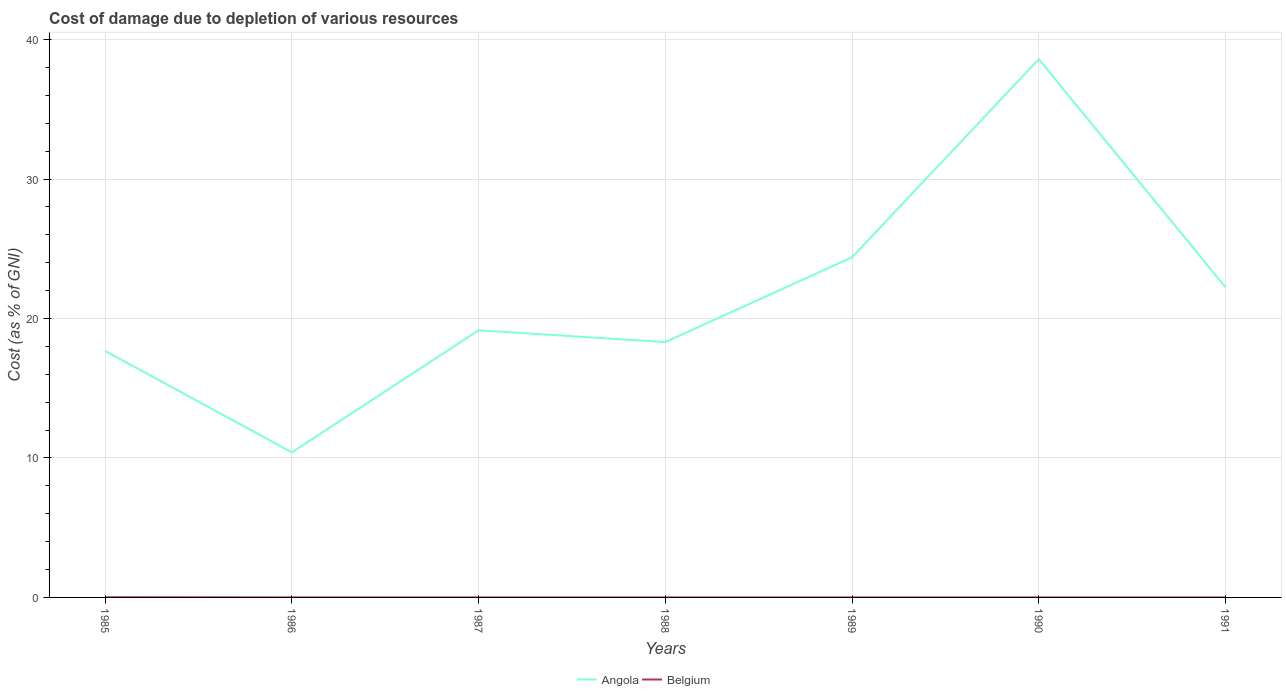Is the number of lines equal to the number of legend labels?
Your answer should be compact. Yes. Across all years, what is the maximum cost of damage caused due to the depletion of various resources in Belgium?
Ensure brevity in your answer.  0. In which year was the cost of damage caused due to the depletion of various resources in Angola maximum?
Offer a very short reply. 1986. What is the total cost of damage caused due to the depletion of various resources in Belgium in the graph?
Your answer should be compact. 3.8111591028627015e-5. What is the difference between the highest and the second highest cost of damage caused due to the depletion of various resources in Belgium?
Offer a very short reply. 0.02. What is the difference between the highest and the lowest cost of damage caused due to the depletion of various resources in Belgium?
Give a very brief answer. 1. How many years are there in the graph?
Offer a terse response. 7. What is the difference between two consecutive major ticks on the Y-axis?
Give a very brief answer. 10. Does the graph contain grids?
Offer a terse response. Yes. How many legend labels are there?
Ensure brevity in your answer.  2. What is the title of the graph?
Offer a very short reply. Cost of damage due to depletion of various resources. What is the label or title of the X-axis?
Make the answer very short. Years. What is the label or title of the Y-axis?
Your answer should be compact. Cost (as % of GNI). What is the Cost (as % of GNI) of Angola in 1985?
Provide a succinct answer. 17.68. What is the Cost (as % of GNI) in Belgium in 1985?
Your answer should be very brief. 0.02. What is the Cost (as % of GNI) in Angola in 1986?
Offer a very short reply. 10.4. What is the Cost (as % of GNI) in Belgium in 1986?
Keep it short and to the point. 0. What is the Cost (as % of GNI) in Angola in 1987?
Keep it short and to the point. 19.15. What is the Cost (as % of GNI) in Belgium in 1987?
Your response must be concise. 0. What is the Cost (as % of GNI) in Angola in 1988?
Ensure brevity in your answer.  18.31. What is the Cost (as % of GNI) in Belgium in 1988?
Your answer should be very brief. 0. What is the Cost (as % of GNI) in Angola in 1989?
Offer a terse response. 24.39. What is the Cost (as % of GNI) of Belgium in 1989?
Your answer should be very brief. 0. What is the Cost (as % of GNI) of Angola in 1990?
Offer a very short reply. 38.59. What is the Cost (as % of GNI) in Belgium in 1990?
Make the answer very short. 0. What is the Cost (as % of GNI) in Angola in 1991?
Your answer should be very brief. 22.24. What is the Cost (as % of GNI) in Belgium in 1991?
Your response must be concise. 0. Across all years, what is the maximum Cost (as % of GNI) of Angola?
Provide a short and direct response. 38.59. Across all years, what is the maximum Cost (as % of GNI) of Belgium?
Give a very brief answer. 0.02. Across all years, what is the minimum Cost (as % of GNI) in Angola?
Your response must be concise. 10.4. Across all years, what is the minimum Cost (as % of GNI) of Belgium?
Your answer should be compact. 0. What is the total Cost (as % of GNI) in Angola in the graph?
Provide a succinct answer. 150.76. What is the total Cost (as % of GNI) of Belgium in the graph?
Your answer should be very brief. 0.02. What is the difference between the Cost (as % of GNI) in Angola in 1985 and that in 1986?
Your answer should be very brief. 7.27. What is the difference between the Cost (as % of GNI) in Belgium in 1985 and that in 1986?
Offer a very short reply. 0.01. What is the difference between the Cost (as % of GNI) of Angola in 1985 and that in 1987?
Your answer should be compact. -1.48. What is the difference between the Cost (as % of GNI) of Belgium in 1985 and that in 1987?
Provide a short and direct response. 0.02. What is the difference between the Cost (as % of GNI) in Angola in 1985 and that in 1988?
Offer a very short reply. -0.63. What is the difference between the Cost (as % of GNI) in Belgium in 1985 and that in 1988?
Your answer should be compact. 0.02. What is the difference between the Cost (as % of GNI) of Angola in 1985 and that in 1989?
Give a very brief answer. -6.71. What is the difference between the Cost (as % of GNI) in Belgium in 1985 and that in 1989?
Provide a succinct answer. 0.02. What is the difference between the Cost (as % of GNI) in Angola in 1985 and that in 1990?
Your response must be concise. -20.92. What is the difference between the Cost (as % of GNI) in Belgium in 1985 and that in 1990?
Offer a very short reply. 0.02. What is the difference between the Cost (as % of GNI) of Angola in 1985 and that in 1991?
Give a very brief answer. -4.56. What is the difference between the Cost (as % of GNI) of Belgium in 1985 and that in 1991?
Ensure brevity in your answer.  0.02. What is the difference between the Cost (as % of GNI) in Angola in 1986 and that in 1987?
Provide a short and direct response. -8.75. What is the difference between the Cost (as % of GNI) in Angola in 1986 and that in 1988?
Ensure brevity in your answer.  -7.91. What is the difference between the Cost (as % of GNI) in Belgium in 1986 and that in 1988?
Provide a short and direct response. 0. What is the difference between the Cost (as % of GNI) in Angola in 1986 and that in 1989?
Make the answer very short. -13.99. What is the difference between the Cost (as % of GNI) in Belgium in 1986 and that in 1989?
Ensure brevity in your answer.  0. What is the difference between the Cost (as % of GNI) in Angola in 1986 and that in 1990?
Offer a terse response. -28.19. What is the difference between the Cost (as % of GNI) of Belgium in 1986 and that in 1990?
Ensure brevity in your answer.  0. What is the difference between the Cost (as % of GNI) in Angola in 1986 and that in 1991?
Make the answer very short. -11.84. What is the difference between the Cost (as % of GNI) in Belgium in 1986 and that in 1991?
Your response must be concise. 0. What is the difference between the Cost (as % of GNI) of Angola in 1987 and that in 1988?
Keep it short and to the point. 0.84. What is the difference between the Cost (as % of GNI) of Angola in 1987 and that in 1989?
Ensure brevity in your answer.  -5.24. What is the difference between the Cost (as % of GNI) of Angola in 1987 and that in 1990?
Make the answer very short. -19.44. What is the difference between the Cost (as % of GNI) in Belgium in 1987 and that in 1990?
Give a very brief answer. 0. What is the difference between the Cost (as % of GNI) of Angola in 1987 and that in 1991?
Make the answer very short. -3.09. What is the difference between the Cost (as % of GNI) of Belgium in 1987 and that in 1991?
Provide a short and direct response. 0. What is the difference between the Cost (as % of GNI) in Angola in 1988 and that in 1989?
Make the answer very short. -6.08. What is the difference between the Cost (as % of GNI) in Belgium in 1988 and that in 1989?
Make the answer very short. 0. What is the difference between the Cost (as % of GNI) in Angola in 1988 and that in 1990?
Give a very brief answer. -20.28. What is the difference between the Cost (as % of GNI) in Angola in 1988 and that in 1991?
Offer a terse response. -3.93. What is the difference between the Cost (as % of GNI) of Angola in 1989 and that in 1990?
Provide a succinct answer. -14.21. What is the difference between the Cost (as % of GNI) in Belgium in 1989 and that in 1990?
Provide a succinct answer. 0. What is the difference between the Cost (as % of GNI) of Angola in 1989 and that in 1991?
Keep it short and to the point. 2.15. What is the difference between the Cost (as % of GNI) in Belgium in 1989 and that in 1991?
Your response must be concise. 0. What is the difference between the Cost (as % of GNI) in Angola in 1990 and that in 1991?
Offer a terse response. 16.36. What is the difference between the Cost (as % of GNI) in Angola in 1985 and the Cost (as % of GNI) in Belgium in 1986?
Offer a very short reply. 17.67. What is the difference between the Cost (as % of GNI) of Angola in 1985 and the Cost (as % of GNI) of Belgium in 1987?
Ensure brevity in your answer.  17.67. What is the difference between the Cost (as % of GNI) of Angola in 1985 and the Cost (as % of GNI) of Belgium in 1988?
Your answer should be very brief. 17.67. What is the difference between the Cost (as % of GNI) in Angola in 1985 and the Cost (as % of GNI) in Belgium in 1989?
Your response must be concise. 17.67. What is the difference between the Cost (as % of GNI) of Angola in 1985 and the Cost (as % of GNI) of Belgium in 1990?
Your answer should be very brief. 17.67. What is the difference between the Cost (as % of GNI) in Angola in 1985 and the Cost (as % of GNI) in Belgium in 1991?
Your answer should be very brief. 17.67. What is the difference between the Cost (as % of GNI) in Angola in 1986 and the Cost (as % of GNI) in Belgium in 1987?
Make the answer very short. 10.4. What is the difference between the Cost (as % of GNI) in Angola in 1986 and the Cost (as % of GNI) in Belgium in 1988?
Offer a very short reply. 10.4. What is the difference between the Cost (as % of GNI) of Angola in 1986 and the Cost (as % of GNI) of Belgium in 1989?
Your answer should be compact. 10.4. What is the difference between the Cost (as % of GNI) of Angola in 1986 and the Cost (as % of GNI) of Belgium in 1990?
Provide a short and direct response. 10.4. What is the difference between the Cost (as % of GNI) in Angola in 1986 and the Cost (as % of GNI) in Belgium in 1991?
Provide a succinct answer. 10.4. What is the difference between the Cost (as % of GNI) in Angola in 1987 and the Cost (as % of GNI) in Belgium in 1988?
Keep it short and to the point. 19.15. What is the difference between the Cost (as % of GNI) in Angola in 1987 and the Cost (as % of GNI) in Belgium in 1989?
Your answer should be very brief. 19.15. What is the difference between the Cost (as % of GNI) in Angola in 1987 and the Cost (as % of GNI) in Belgium in 1990?
Ensure brevity in your answer.  19.15. What is the difference between the Cost (as % of GNI) of Angola in 1987 and the Cost (as % of GNI) of Belgium in 1991?
Your answer should be very brief. 19.15. What is the difference between the Cost (as % of GNI) of Angola in 1988 and the Cost (as % of GNI) of Belgium in 1989?
Your response must be concise. 18.31. What is the difference between the Cost (as % of GNI) in Angola in 1988 and the Cost (as % of GNI) in Belgium in 1990?
Give a very brief answer. 18.31. What is the difference between the Cost (as % of GNI) of Angola in 1988 and the Cost (as % of GNI) of Belgium in 1991?
Your response must be concise. 18.31. What is the difference between the Cost (as % of GNI) of Angola in 1989 and the Cost (as % of GNI) of Belgium in 1990?
Provide a short and direct response. 24.39. What is the difference between the Cost (as % of GNI) of Angola in 1989 and the Cost (as % of GNI) of Belgium in 1991?
Your answer should be compact. 24.39. What is the difference between the Cost (as % of GNI) of Angola in 1990 and the Cost (as % of GNI) of Belgium in 1991?
Provide a succinct answer. 38.59. What is the average Cost (as % of GNI) in Angola per year?
Give a very brief answer. 21.54. What is the average Cost (as % of GNI) in Belgium per year?
Ensure brevity in your answer.  0. In the year 1985, what is the difference between the Cost (as % of GNI) of Angola and Cost (as % of GNI) of Belgium?
Offer a terse response. 17.66. In the year 1986, what is the difference between the Cost (as % of GNI) in Angola and Cost (as % of GNI) in Belgium?
Ensure brevity in your answer.  10.4. In the year 1987, what is the difference between the Cost (as % of GNI) of Angola and Cost (as % of GNI) of Belgium?
Make the answer very short. 19.15. In the year 1988, what is the difference between the Cost (as % of GNI) of Angola and Cost (as % of GNI) of Belgium?
Provide a short and direct response. 18.31. In the year 1989, what is the difference between the Cost (as % of GNI) of Angola and Cost (as % of GNI) of Belgium?
Your answer should be compact. 24.39. In the year 1990, what is the difference between the Cost (as % of GNI) in Angola and Cost (as % of GNI) in Belgium?
Give a very brief answer. 38.59. In the year 1991, what is the difference between the Cost (as % of GNI) of Angola and Cost (as % of GNI) of Belgium?
Give a very brief answer. 22.24. What is the ratio of the Cost (as % of GNI) of Angola in 1985 to that in 1986?
Give a very brief answer. 1.7. What is the ratio of the Cost (as % of GNI) in Belgium in 1985 to that in 1986?
Keep it short and to the point. 14.12. What is the ratio of the Cost (as % of GNI) of Angola in 1985 to that in 1987?
Keep it short and to the point. 0.92. What is the ratio of the Cost (as % of GNI) in Belgium in 1985 to that in 1987?
Keep it short and to the point. 24.03. What is the ratio of the Cost (as % of GNI) in Angola in 1985 to that in 1988?
Your answer should be compact. 0.97. What is the ratio of the Cost (as % of GNI) in Belgium in 1985 to that in 1988?
Keep it short and to the point. 48.03. What is the ratio of the Cost (as % of GNI) of Angola in 1985 to that in 1989?
Give a very brief answer. 0.72. What is the ratio of the Cost (as % of GNI) in Belgium in 1985 to that in 1989?
Your response must be concise. 69.32. What is the ratio of the Cost (as % of GNI) in Angola in 1985 to that in 1990?
Make the answer very short. 0.46. What is the ratio of the Cost (as % of GNI) in Belgium in 1985 to that in 1990?
Provide a short and direct response. 73.58. What is the ratio of the Cost (as % of GNI) in Angola in 1985 to that in 1991?
Give a very brief answer. 0.79. What is the ratio of the Cost (as % of GNI) of Belgium in 1985 to that in 1991?
Offer a very short reply. 89.11. What is the ratio of the Cost (as % of GNI) of Angola in 1986 to that in 1987?
Make the answer very short. 0.54. What is the ratio of the Cost (as % of GNI) in Belgium in 1986 to that in 1987?
Your response must be concise. 1.7. What is the ratio of the Cost (as % of GNI) in Angola in 1986 to that in 1988?
Offer a very short reply. 0.57. What is the ratio of the Cost (as % of GNI) in Belgium in 1986 to that in 1988?
Your answer should be compact. 3.4. What is the ratio of the Cost (as % of GNI) of Angola in 1986 to that in 1989?
Provide a short and direct response. 0.43. What is the ratio of the Cost (as % of GNI) in Belgium in 1986 to that in 1989?
Your answer should be very brief. 4.91. What is the ratio of the Cost (as % of GNI) of Angola in 1986 to that in 1990?
Your answer should be very brief. 0.27. What is the ratio of the Cost (as % of GNI) of Belgium in 1986 to that in 1990?
Your response must be concise. 5.21. What is the ratio of the Cost (as % of GNI) of Angola in 1986 to that in 1991?
Keep it short and to the point. 0.47. What is the ratio of the Cost (as % of GNI) of Belgium in 1986 to that in 1991?
Offer a terse response. 6.31. What is the ratio of the Cost (as % of GNI) in Angola in 1987 to that in 1988?
Ensure brevity in your answer.  1.05. What is the ratio of the Cost (as % of GNI) in Belgium in 1987 to that in 1988?
Keep it short and to the point. 2. What is the ratio of the Cost (as % of GNI) in Angola in 1987 to that in 1989?
Offer a very short reply. 0.79. What is the ratio of the Cost (as % of GNI) of Belgium in 1987 to that in 1989?
Offer a terse response. 2.88. What is the ratio of the Cost (as % of GNI) in Angola in 1987 to that in 1990?
Your response must be concise. 0.5. What is the ratio of the Cost (as % of GNI) of Belgium in 1987 to that in 1990?
Your answer should be compact. 3.06. What is the ratio of the Cost (as % of GNI) of Angola in 1987 to that in 1991?
Your answer should be compact. 0.86. What is the ratio of the Cost (as % of GNI) of Belgium in 1987 to that in 1991?
Offer a terse response. 3.71. What is the ratio of the Cost (as % of GNI) in Angola in 1988 to that in 1989?
Your answer should be very brief. 0.75. What is the ratio of the Cost (as % of GNI) in Belgium in 1988 to that in 1989?
Make the answer very short. 1.44. What is the ratio of the Cost (as % of GNI) in Angola in 1988 to that in 1990?
Give a very brief answer. 0.47. What is the ratio of the Cost (as % of GNI) in Belgium in 1988 to that in 1990?
Make the answer very short. 1.53. What is the ratio of the Cost (as % of GNI) in Angola in 1988 to that in 1991?
Your answer should be compact. 0.82. What is the ratio of the Cost (as % of GNI) of Belgium in 1988 to that in 1991?
Your answer should be very brief. 1.86. What is the ratio of the Cost (as % of GNI) in Angola in 1989 to that in 1990?
Your answer should be compact. 0.63. What is the ratio of the Cost (as % of GNI) in Belgium in 1989 to that in 1990?
Provide a succinct answer. 1.06. What is the ratio of the Cost (as % of GNI) of Angola in 1989 to that in 1991?
Provide a succinct answer. 1.1. What is the ratio of the Cost (as % of GNI) in Belgium in 1989 to that in 1991?
Offer a very short reply. 1.29. What is the ratio of the Cost (as % of GNI) of Angola in 1990 to that in 1991?
Your answer should be compact. 1.74. What is the ratio of the Cost (as % of GNI) in Belgium in 1990 to that in 1991?
Offer a terse response. 1.21. What is the difference between the highest and the second highest Cost (as % of GNI) in Angola?
Make the answer very short. 14.21. What is the difference between the highest and the second highest Cost (as % of GNI) of Belgium?
Offer a very short reply. 0.01. What is the difference between the highest and the lowest Cost (as % of GNI) of Angola?
Offer a very short reply. 28.19. What is the difference between the highest and the lowest Cost (as % of GNI) in Belgium?
Your response must be concise. 0.02. 